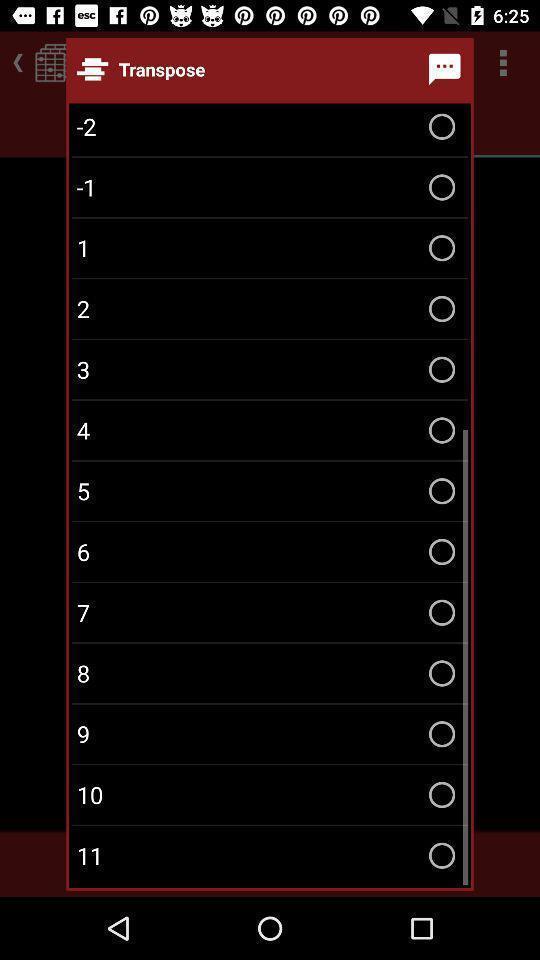Tell me what you see in this picture. Popup showing list of transpose 's to select on an app. 